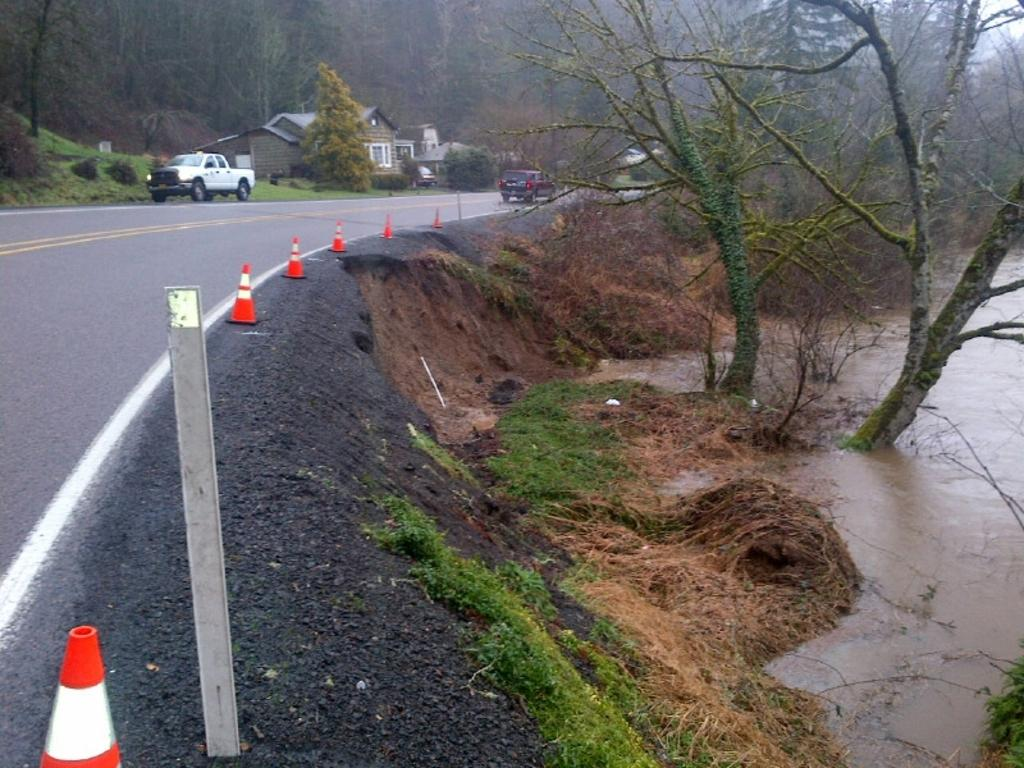How many cars can be seen in the image? There are two cars in the image. What are the cars doing in the image? The cars are passing on a road surface. What can be seen on either side of the road? There are trees and houses on either side of the road. How does the stomach of the car feel while driving on the road? Cars do not have stomachs, so this question cannot be answered. 